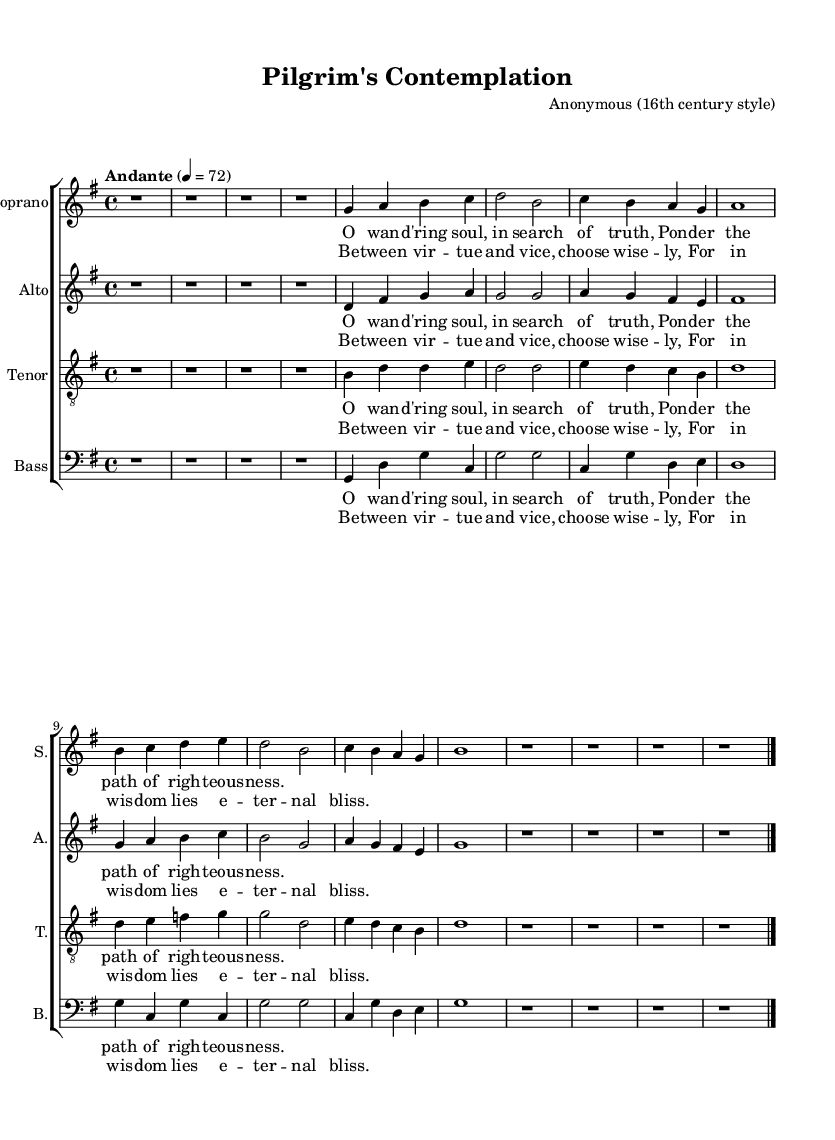What is the key signature of this music? The key signature is G major, which has one sharp (F#). This can be determined from the key indication written at the beginning of the score, denoted as "g" in the global context section.
Answer: G major What is the time signature of this music? The time signature is 4/4, as indicated immediately after the key signature in the global context of the score. This means there are four beats per measure, with each beat being a quarter note.
Answer: 4/4 What is the tempo marking for this piece? The tempo marking is "Andante," which conveys a moderate pace. This is specified in the tempo instruction given in the global section of the music.
Answer: Andante How many verses of lyrics are provided in this composition? There are two verses of lyrics in the score, as indicated by the separate lyric sections labeled verseOne and verseTwo under each voice part. Each verse is repeated for all voices.
Answer: Two Which vocal parts are included in the piece? The vocal parts included are Soprano, Alto, Tenor, and Bass. This can be identified from the labels above each staff in the score, indicating the respective voice parts.
Answer: Soprano, Alto, Tenor, Bass What theological concept is primarily explored in the lyrics of this piece? The lyrics revolve around the theme of moral choice, contrasting virtue and vice. This is evident from the lines discussing wisdom and righteousness, connecting to broader theological discussions about living a virtuous life.
Answer: Moral choice What is the predominant musical texture used in this sacred polyphony? The predominant musical texture is polyphonic, characterized by the interweaving melodies of the various vocal parts creating a rich harmonic framework. This is typical of Renaissance sacred music where multiple independent melodies are sung simultaneously.
Answer: Polyphonic 